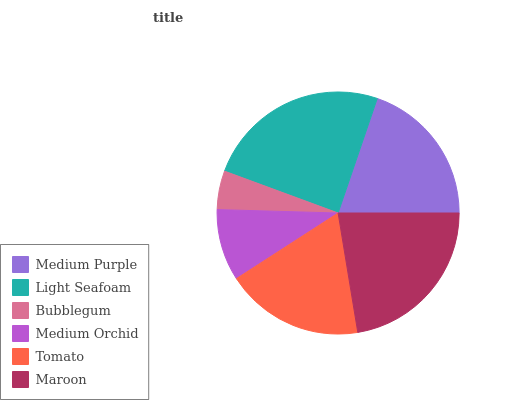Is Bubblegum the minimum?
Answer yes or no. Yes. Is Light Seafoam the maximum?
Answer yes or no. Yes. Is Light Seafoam the minimum?
Answer yes or no. No. Is Bubblegum the maximum?
Answer yes or no. No. Is Light Seafoam greater than Bubblegum?
Answer yes or no. Yes. Is Bubblegum less than Light Seafoam?
Answer yes or no. Yes. Is Bubblegum greater than Light Seafoam?
Answer yes or no. No. Is Light Seafoam less than Bubblegum?
Answer yes or no. No. Is Medium Purple the high median?
Answer yes or no. Yes. Is Tomato the low median?
Answer yes or no. Yes. Is Maroon the high median?
Answer yes or no. No. Is Light Seafoam the low median?
Answer yes or no. No. 